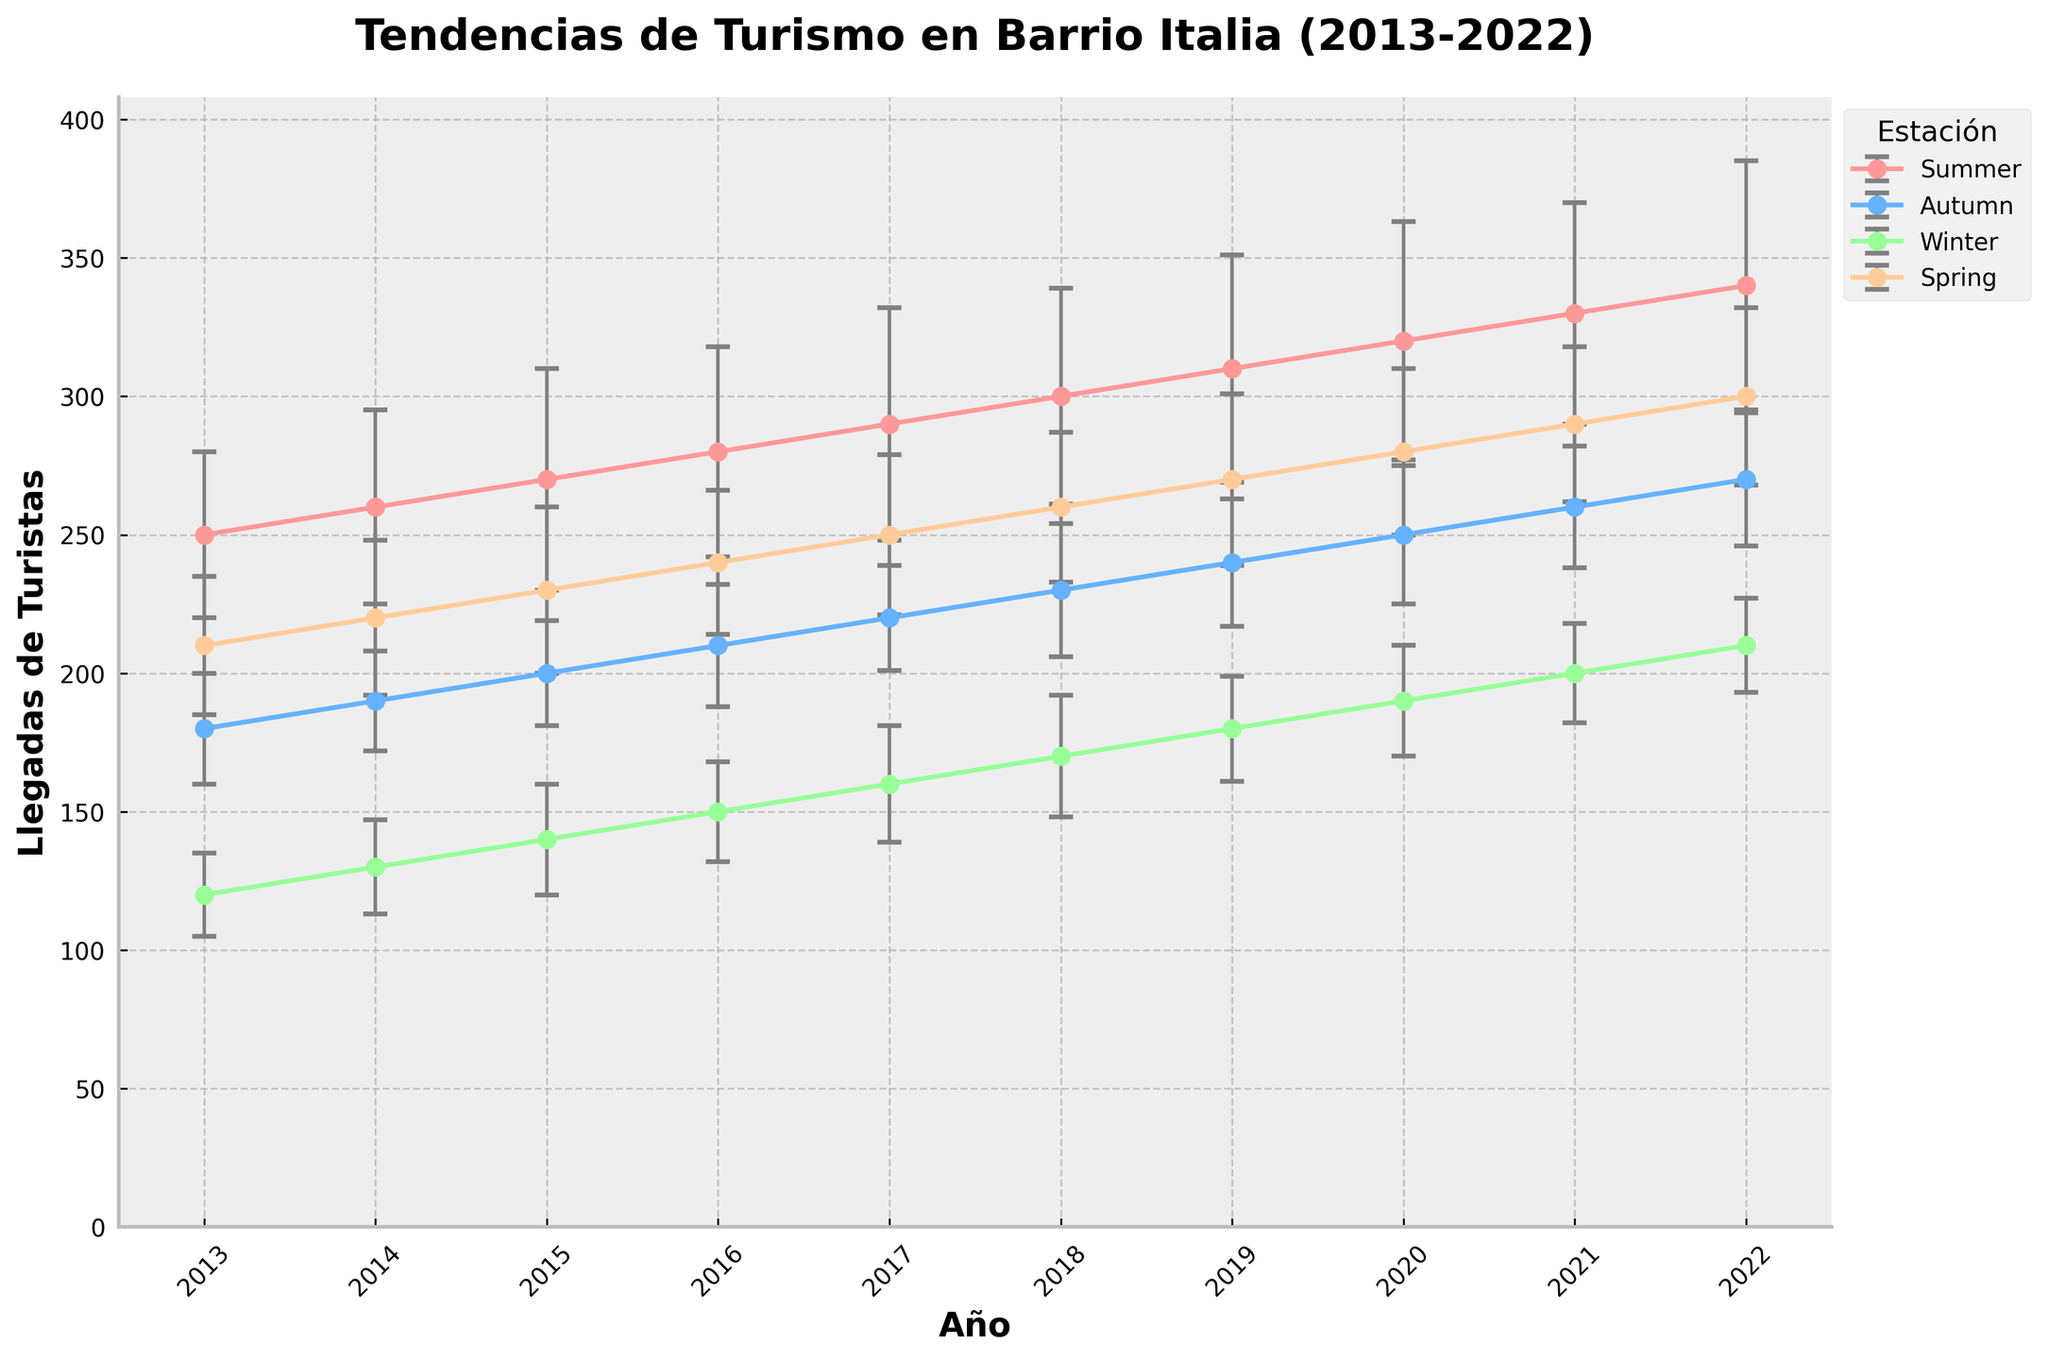¿Cuál es el año con el mayor número de llegadas de turistas en verano? Observando la línea correspondiente a la temporada de verano, notamos que el punto más alto en la gráfica se encuentra en el año 2022 con 340 llegadas.
Answer: 2022 ¿Cuántos turistas aproximadamente llegaron en invierno del año 2016? Buscando en la gráfica la línea que representa el invierno y yendo al año 2016, el promedio de llegadas está alrededor de 150 turistas.
Answer: 150 ¿Cómo se compara el número de turistas en primavera en los años 2013 y 2020? En la gráfica, para el año 2013, vemos que la primavera tuvo 210 llegadas. Para el año 2020, la primavera tuvo 280 llegadas. Comparando ambos, 280 es mayor que 210.
Answer: 280 es mayor que 210 ¿Cuál ha sido el cambio en el número de llegadas de turistas en otoño entre los años 2015 y 2021? La gráfica muestra que en 2015 hubo 200 llegadas en otoño y en 2021 hubo 260. La diferencia es 60 turistas (260 - 200).
Answer: 60 turistas ¿Qué estación muestra la mayor diferencia anual en el promedio de llegadas de turistas entre 2013 y 2022? Comparando las líneas de cada estación año por año, la estación de verano muestra la mayor diferencia de 340 - 250 = 90 llegadas.
Answer: Verano ¿Cuál es la estación con la menor variación en el número de turistas durante la década? Observando la longitud de las barras de error a lo largo del tiempo, la estación de invierno parece tener la menor variación en comparación con las otras estaciones.
Answer: Invierno ¿Qué tendencia general se observa para el turismo en Barrio Italia a lo largo de los años? Observando todas las líneas juntas, notamos que, en general, el número de turistas ha aumentado en todas las temporadas desde 2013 hasta 2022.
Answer: Incremento general ¿Qué estación tiene el valor más bajo de llegadas de turistas y en qué año ocurrió? Observando la gráfica, la llegada más baja ocurre en invierno de 2013, con aproximadamente 120 llegadas.
Answer: Invierno 2013 ¿Qué diferencia se observa en las llegadas promedio de turistas en verano entre 2014 y 2017? El promedio de llegadas en verano de 2014 fue 260, mientras que en 2017 fue 290. La diferencia es de 30 llegadas (290 - 260).
Answer: 30 llegadas ¿Cuál fue la variación máxima en la desviación estándar a lo largo de la década? Observar las barras de error en todas las estaciones y años revela que la desviación estándar varió de 15 a 45, siendo 45 - 15 = 30 la variación máxima.
Answer: 30 